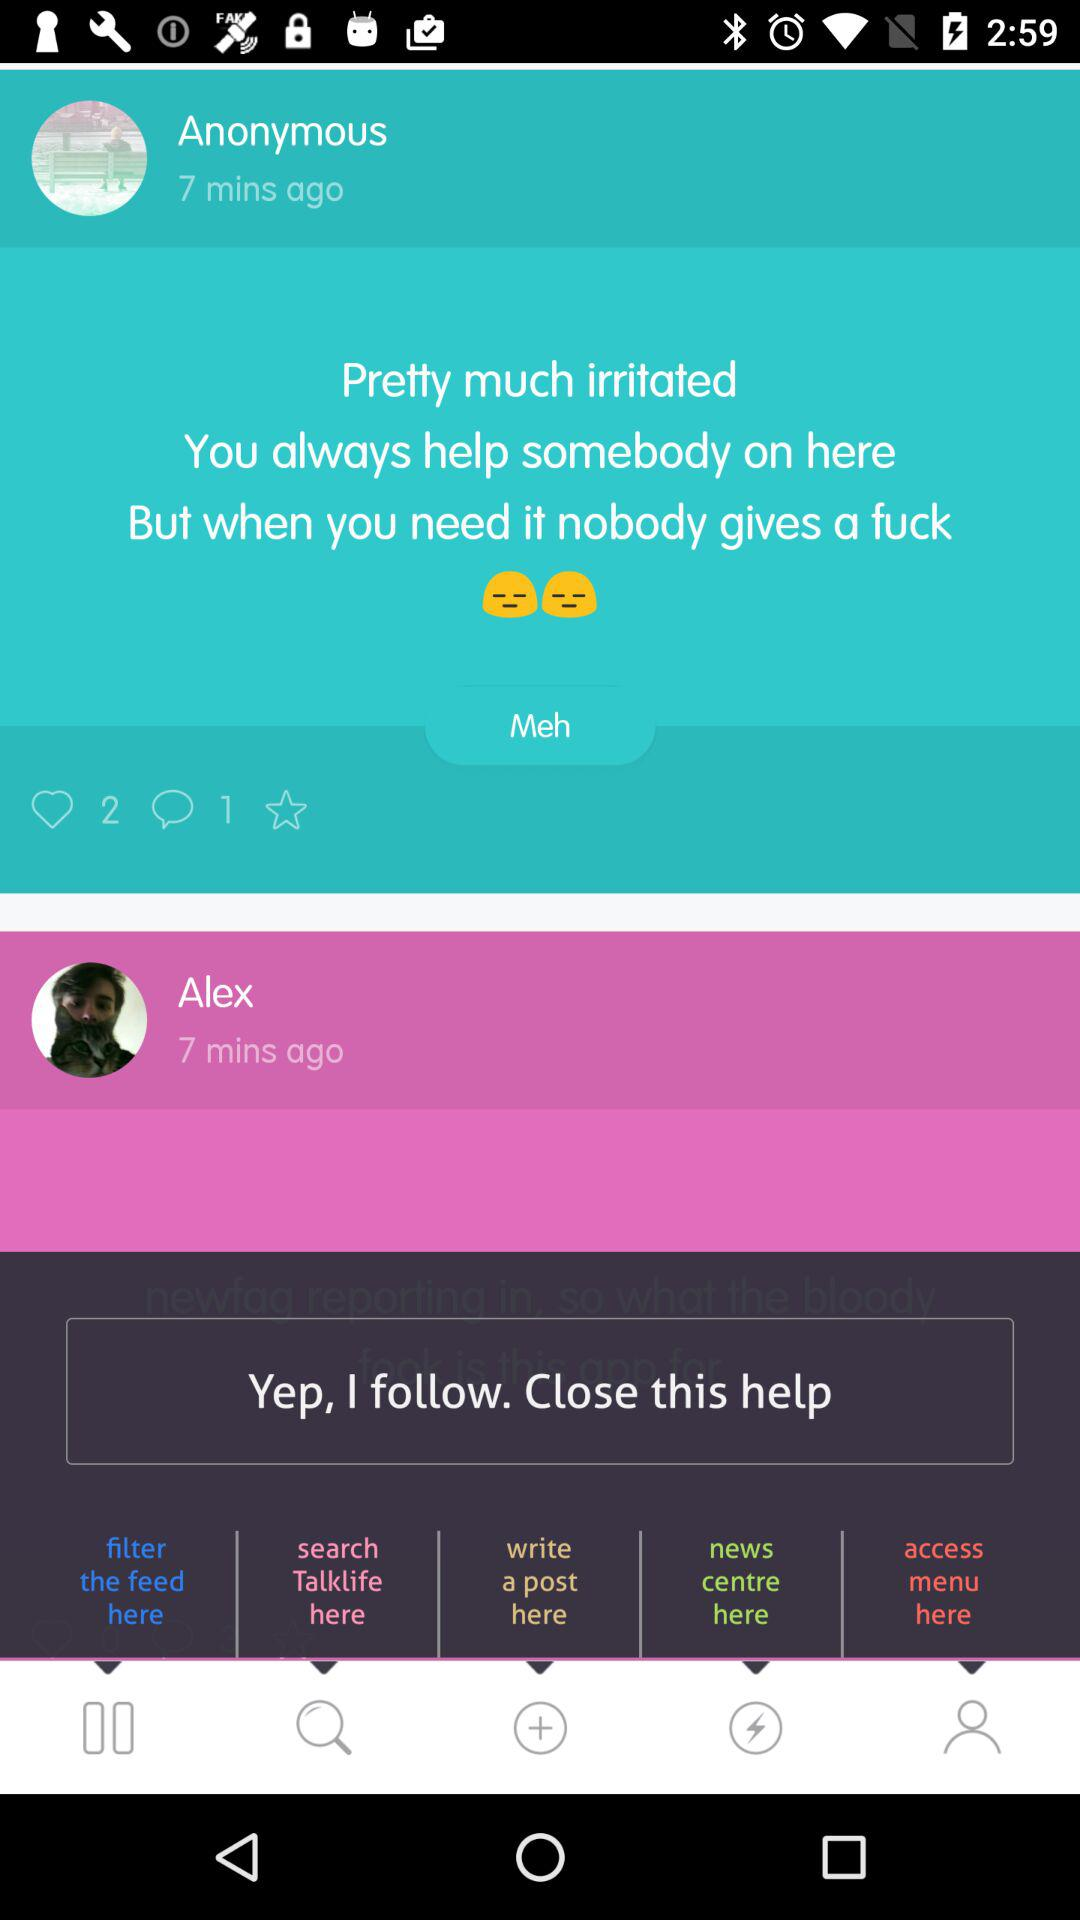How many likes are there? There are 2 likes. 